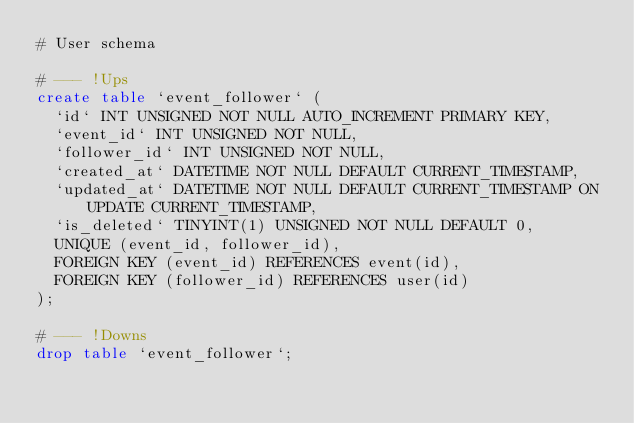Convert code to text. <code><loc_0><loc_0><loc_500><loc_500><_SQL_># User schema

# --- !Ups
create table `event_follower` (
  `id` INT UNSIGNED NOT NULL AUTO_INCREMENT PRIMARY KEY,
  `event_id` INT UNSIGNED NOT NULL,
  `follower_id` INT UNSIGNED NOT NULL,
  `created_at` DATETIME NOT NULL DEFAULT CURRENT_TIMESTAMP,
  `updated_at` DATETIME NOT NULL DEFAULT CURRENT_TIMESTAMP ON UPDATE CURRENT_TIMESTAMP,
  `is_deleted` TINYINT(1) UNSIGNED NOT NULL DEFAULT 0,
  UNIQUE (event_id, follower_id),
  FOREIGN KEY (event_id) REFERENCES event(id),
  FOREIGN KEY (follower_id) REFERENCES user(id)
);

# --- !Downs
drop table `event_follower`;
</code> 